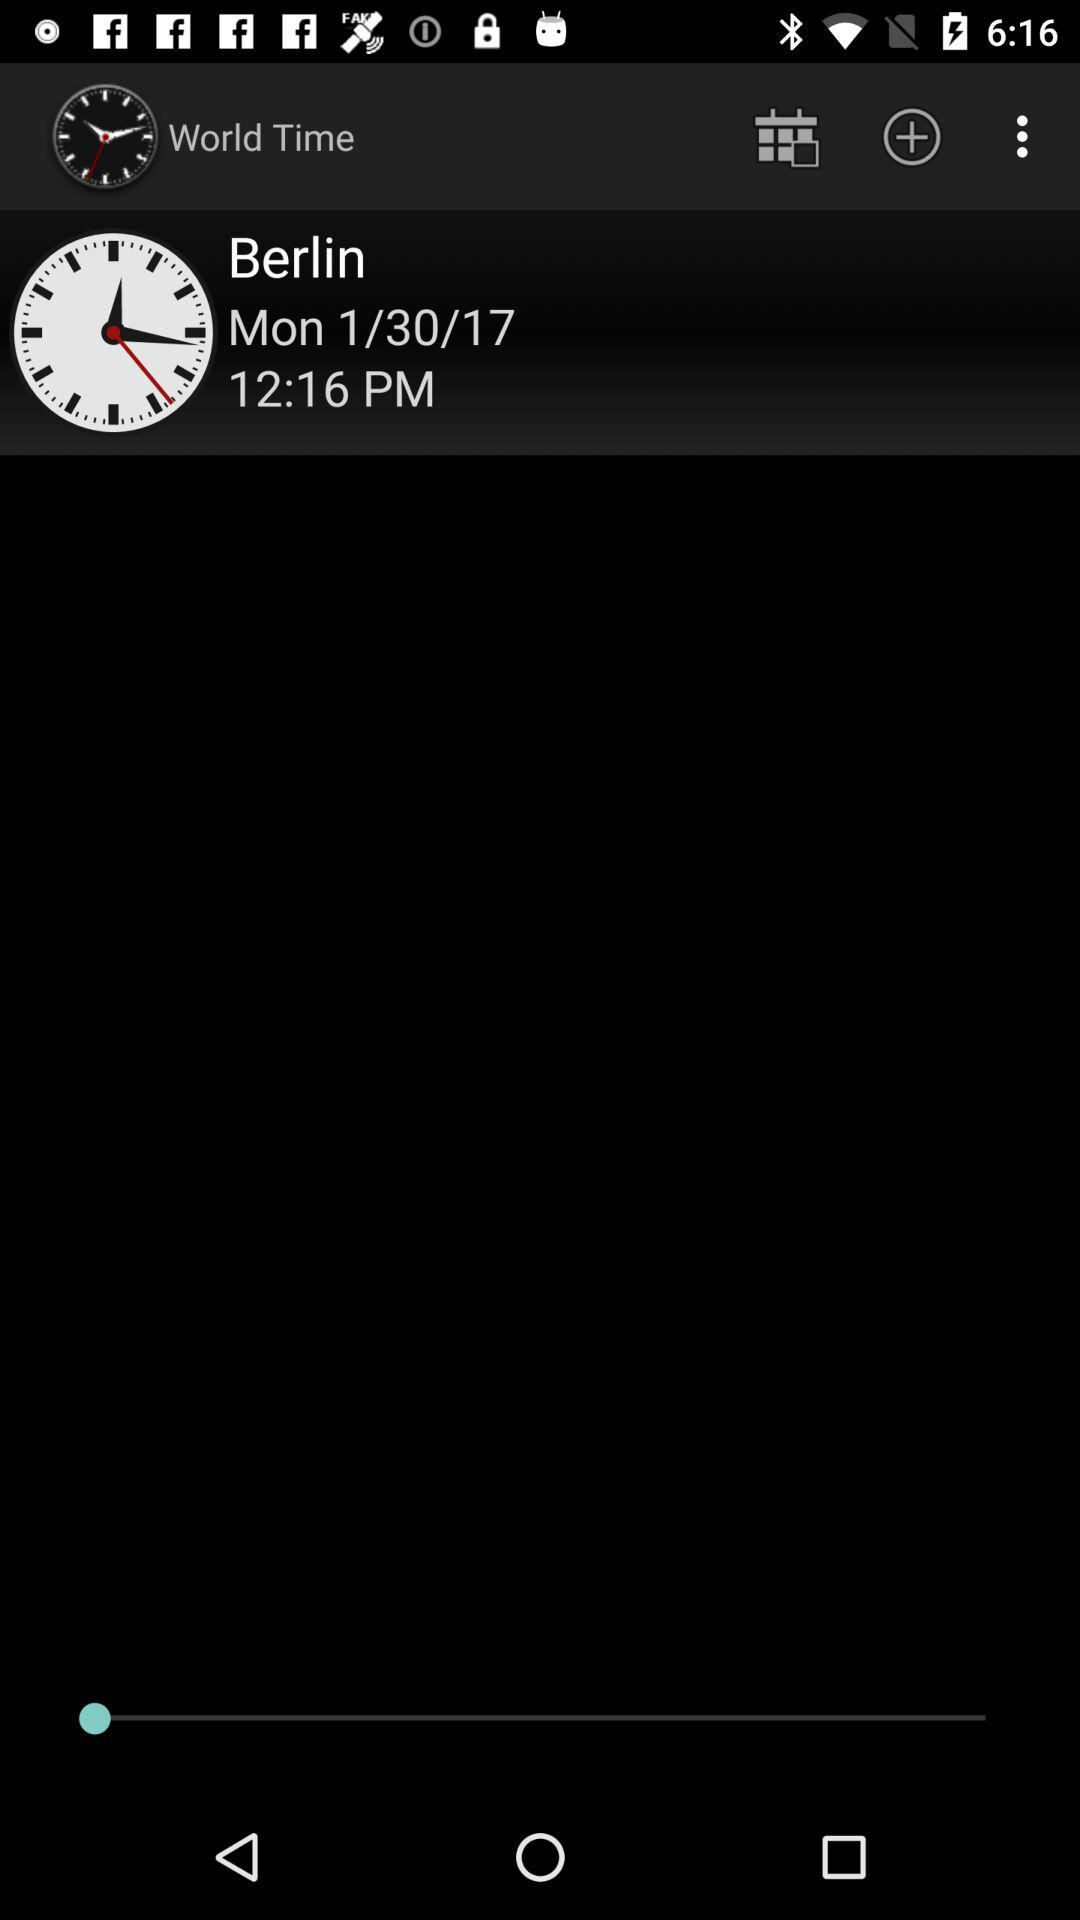What is the day? The day is Monday. 